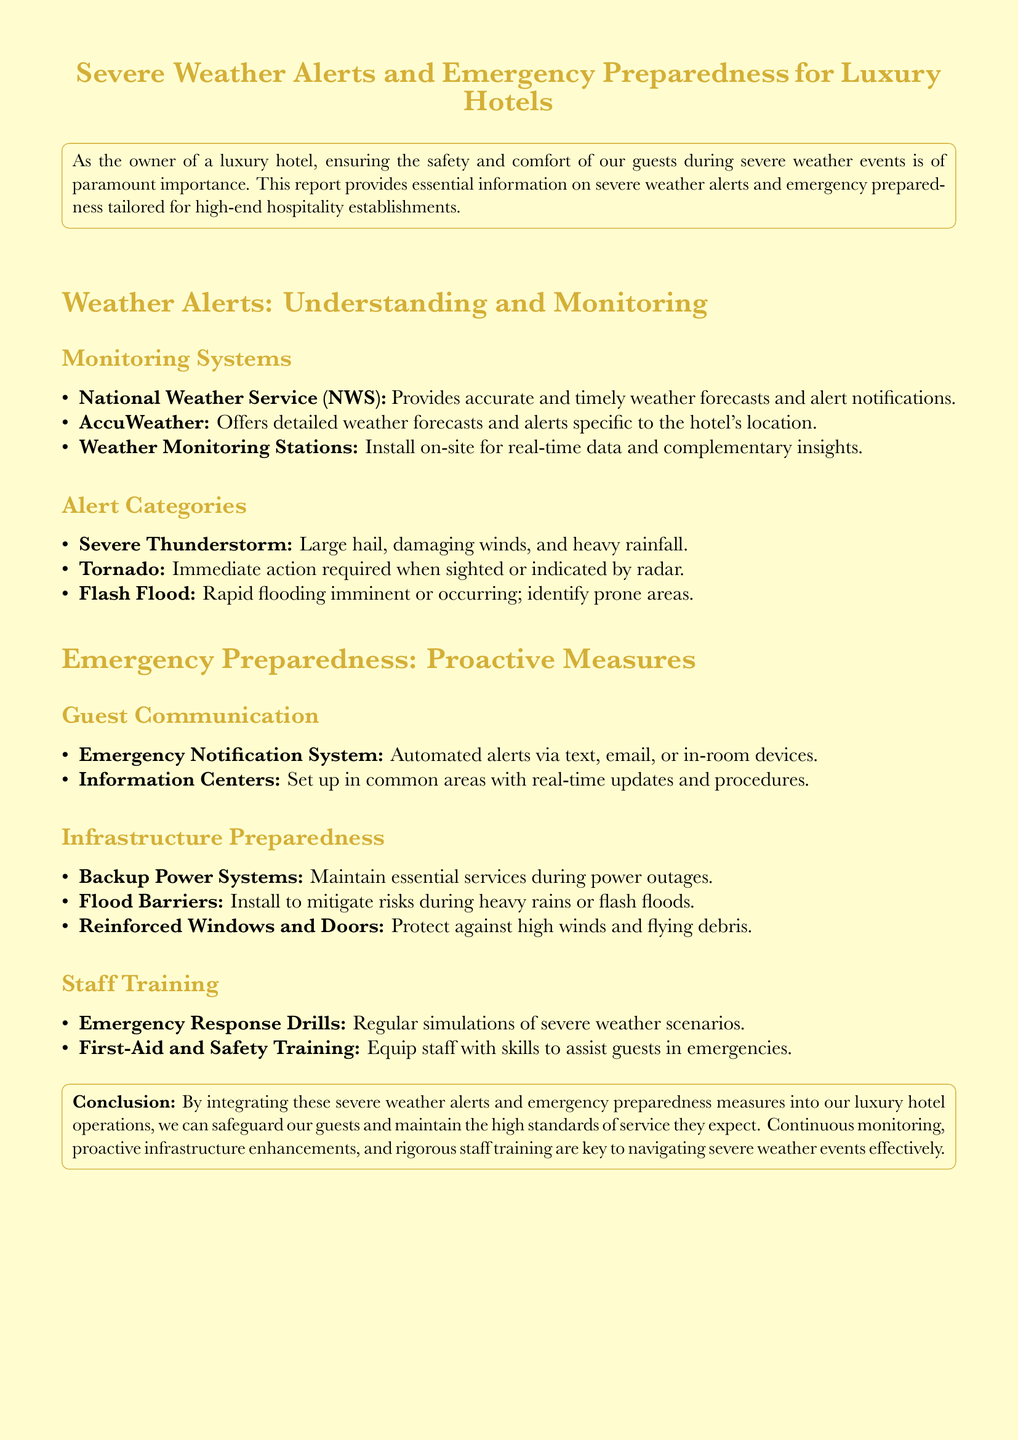What is the main focus of the report? The main focus of the report is on severe weather alerts and emergency preparedness for luxury hotels.
Answer: severe weather alerts and emergency preparedness for luxury hotels Which organization provides accurate weather forecasts? The organization that provides accurate weather forecasts is the National Weather Service.
Answer: National Weather Service What type of severe weather event requires immediate action? The type of severe weather event that requires immediate action is a tornado.
Answer: tornado What is one suitable infrastructure preparedness measure? One suitable infrastructure preparedness measure mentioned is flood barriers.
Answer: flood barriers What is the purpose of the Emergency Notification System? The purpose of the Emergency Notification System is to send automated alerts via text, email, or in-room devices.
Answer: automated alerts via text, email, or in-room devices How often should emergency response drills be conducted? Emergency response drills should be conducted regularly.
Answer: regularly What color is used for the title text? The color used for the title text is gold accent.
Answer: gold accent What should be installed on-site for real-time weather data? Weather monitoring stations should be installed on-site for real-time data.
Answer: Weather monitoring stations What type of training should staff undergo? Staff should undergo first-aid and safety training.
Answer: first-aid and safety training 